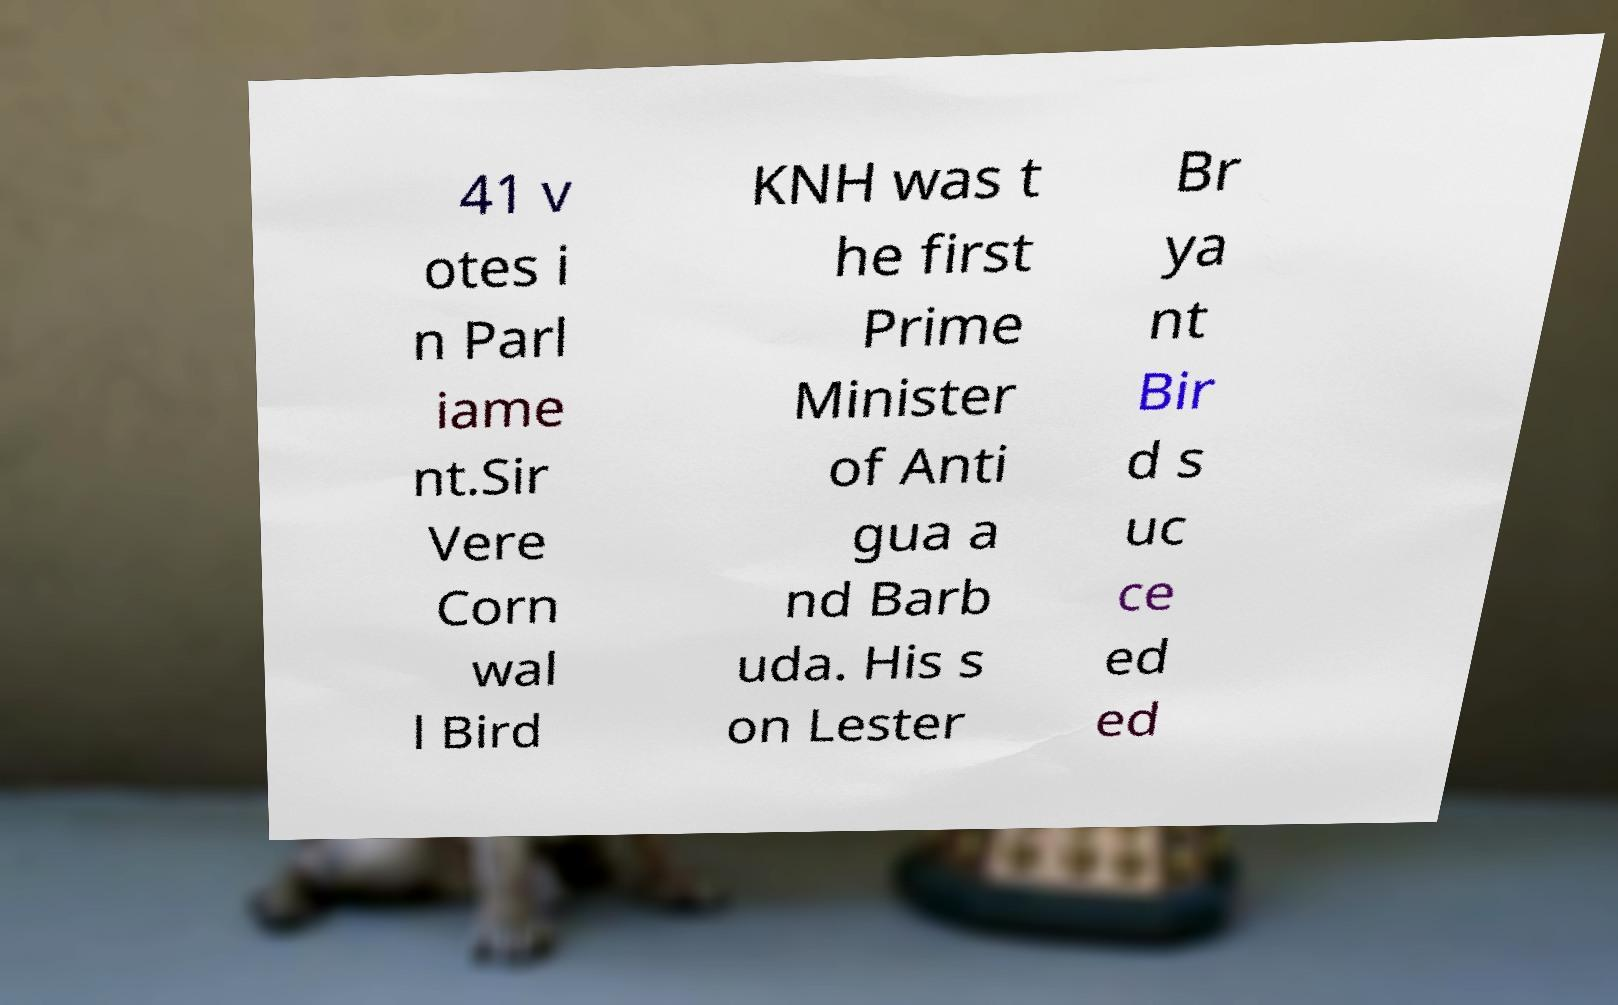I need the written content from this picture converted into text. Can you do that? 41 v otes i n Parl iame nt.Sir Vere Corn wal l Bird KNH was t he first Prime Minister of Anti gua a nd Barb uda. His s on Lester Br ya nt Bir d s uc ce ed ed 